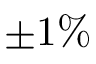<formula> <loc_0><loc_0><loc_500><loc_500>\pm 1 \%</formula> 